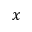<formula> <loc_0><loc_0><loc_500><loc_500>x</formula> 